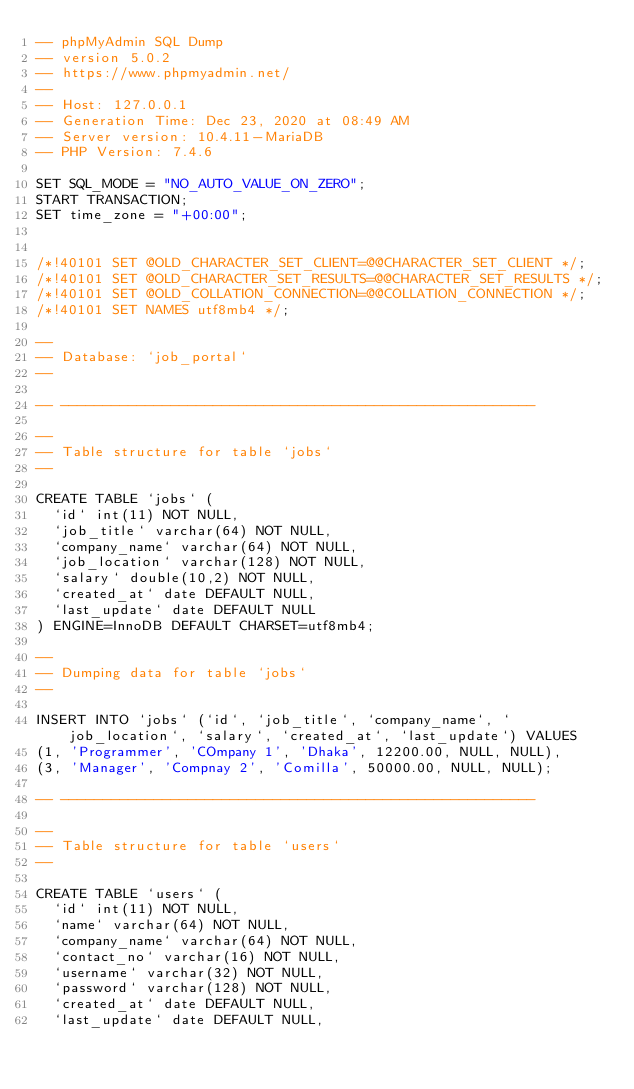<code> <loc_0><loc_0><loc_500><loc_500><_SQL_>-- phpMyAdmin SQL Dump
-- version 5.0.2
-- https://www.phpmyadmin.net/
--
-- Host: 127.0.0.1
-- Generation Time: Dec 23, 2020 at 08:49 AM
-- Server version: 10.4.11-MariaDB
-- PHP Version: 7.4.6

SET SQL_MODE = "NO_AUTO_VALUE_ON_ZERO";
START TRANSACTION;
SET time_zone = "+00:00";


/*!40101 SET @OLD_CHARACTER_SET_CLIENT=@@CHARACTER_SET_CLIENT */;
/*!40101 SET @OLD_CHARACTER_SET_RESULTS=@@CHARACTER_SET_RESULTS */;
/*!40101 SET @OLD_COLLATION_CONNECTION=@@COLLATION_CONNECTION */;
/*!40101 SET NAMES utf8mb4 */;

--
-- Database: `job_portal`
--

-- --------------------------------------------------------

--
-- Table structure for table `jobs`
--

CREATE TABLE `jobs` (
  `id` int(11) NOT NULL,
  `job_title` varchar(64) NOT NULL,
  `company_name` varchar(64) NOT NULL,
  `job_location` varchar(128) NOT NULL,
  `salary` double(10,2) NOT NULL,
  `created_at` date DEFAULT NULL,
  `last_update` date DEFAULT NULL
) ENGINE=InnoDB DEFAULT CHARSET=utf8mb4;

--
-- Dumping data for table `jobs`
--

INSERT INTO `jobs` (`id`, `job_title`, `company_name`, `job_location`, `salary`, `created_at`, `last_update`) VALUES
(1, 'Programmer', 'COmpany 1', 'Dhaka', 12200.00, NULL, NULL),
(3, 'Manager', 'Compnay 2', 'Comilla', 50000.00, NULL, NULL);

-- --------------------------------------------------------

--
-- Table structure for table `users`
--

CREATE TABLE `users` (
  `id` int(11) NOT NULL,
  `name` varchar(64) NOT NULL,
  `company_name` varchar(64) NOT NULL,
  `contact_no` varchar(16) NOT NULL,
  `username` varchar(32) NOT NULL,
  `password` varchar(128) NOT NULL,
  `created_at` date DEFAULT NULL,
  `last_update` date DEFAULT NULL,</code> 